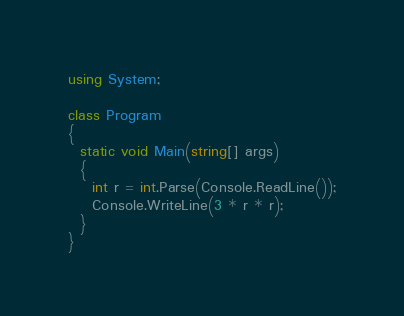<code> <loc_0><loc_0><loc_500><loc_500><_C#_>using System;

class Program
{
  static void Main(string[] args)
  {
    int r = int.Parse(Console.ReadLine());
    Console.WriteLine(3 * r * r);
  }
}</code> 